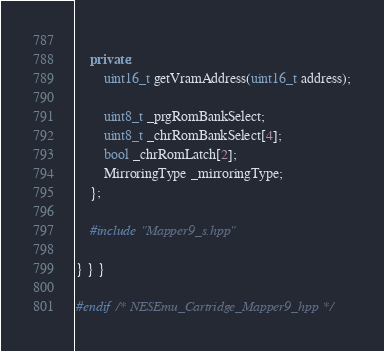<code> <loc_0><loc_0><loc_500><loc_500><_C++_>        
    private:
        uint16_t getVramAddress(uint16_t address);
        
        uint8_t _prgRomBankSelect;
        uint8_t _chrRomBankSelect[4];
        bool _chrRomLatch[2];
        MirroringType _mirroringType;
    };
    
    #include "Mapper9_s.hpp"
    
} } }

#endif /* NESEmu_Cartridge_Mapper9_hpp */
</code> 